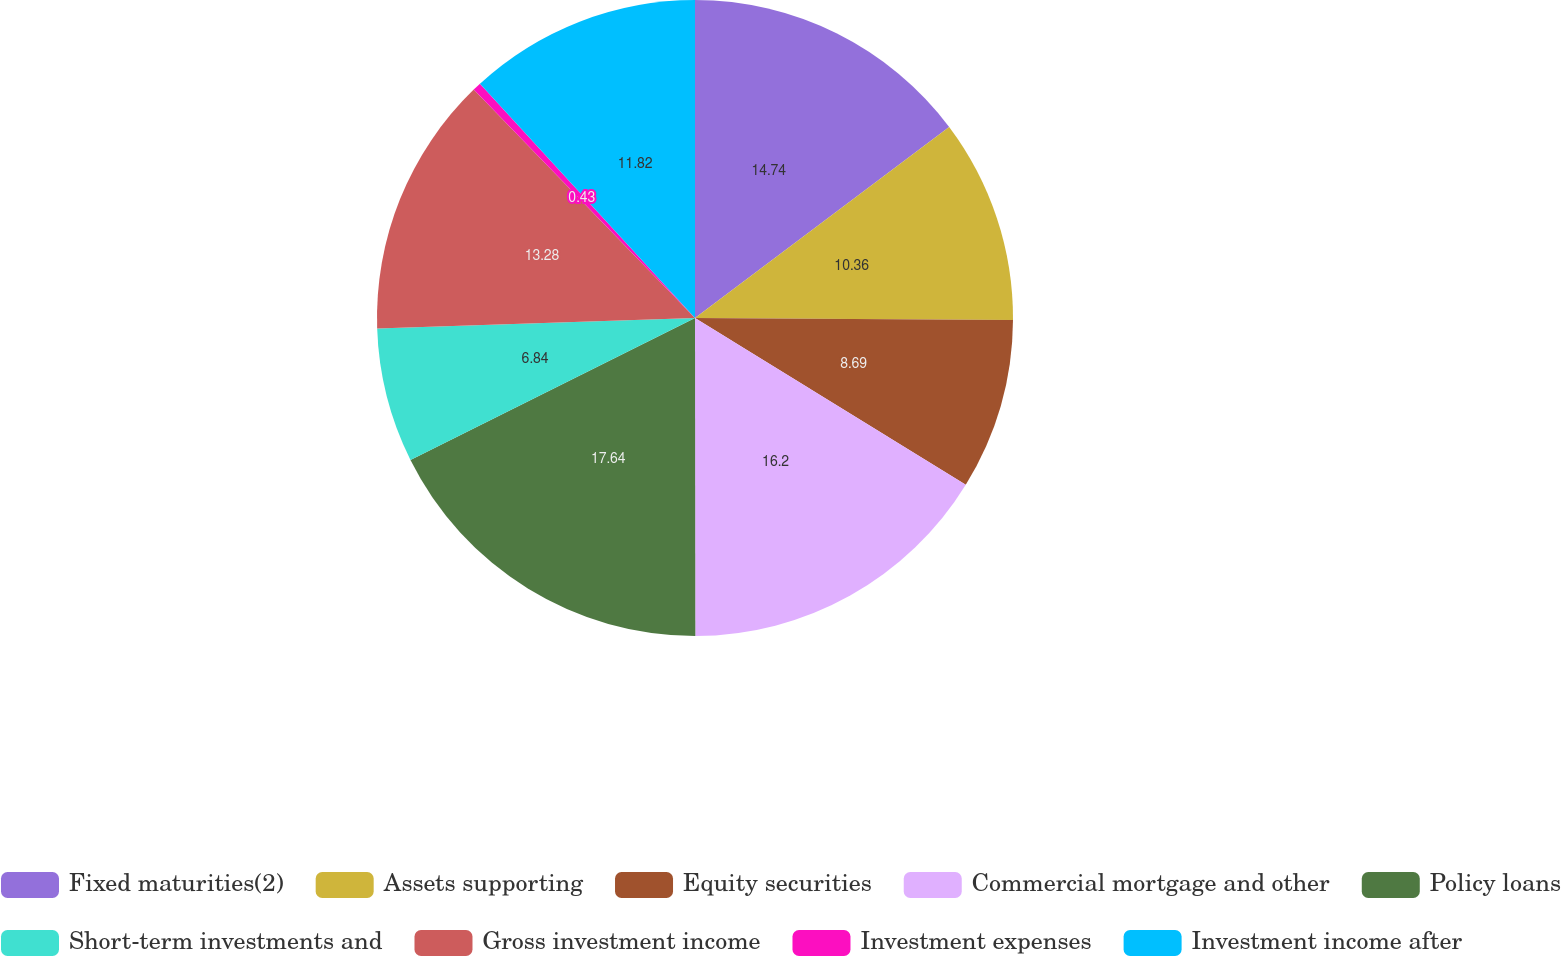Convert chart to OTSL. <chart><loc_0><loc_0><loc_500><loc_500><pie_chart><fcel>Fixed maturities(2)<fcel>Assets supporting<fcel>Equity securities<fcel>Commercial mortgage and other<fcel>Policy loans<fcel>Short-term investments and<fcel>Gross investment income<fcel>Investment expenses<fcel>Investment income after<nl><fcel>14.74%<fcel>10.36%<fcel>8.69%<fcel>16.2%<fcel>17.65%<fcel>6.84%<fcel>13.28%<fcel>0.43%<fcel>11.82%<nl></chart> 